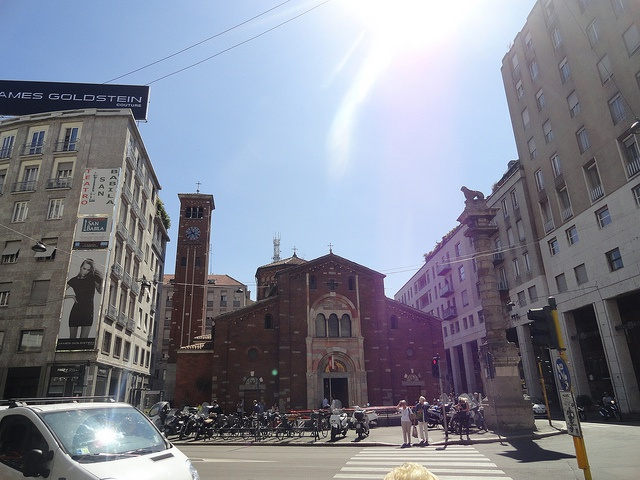Describe the objects in this image and their specific colors. I can see car in gray, white, darkgray, and black tones, traffic light in gray, black, darkgray, and beige tones, motorcycle in gray, black, and lightgray tones, people in gray and purple tones, and bicycle in gray, black, and darkgray tones in this image. 